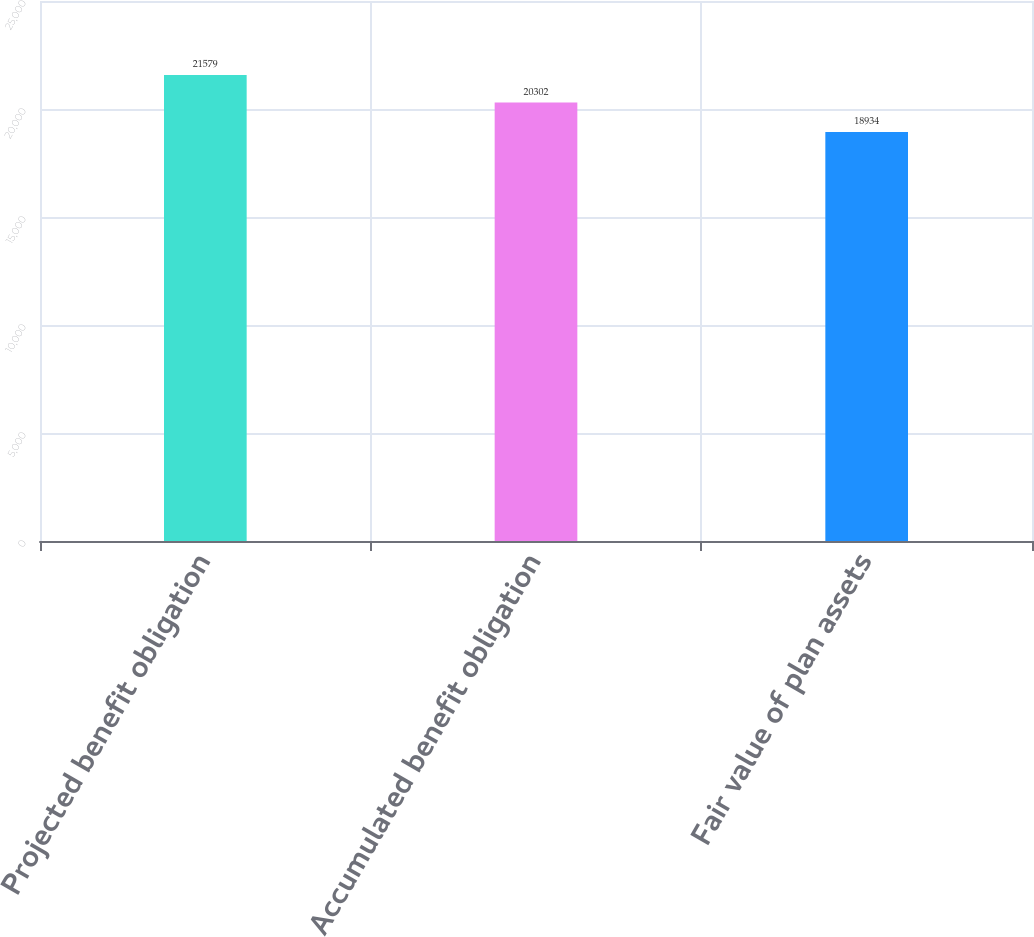<chart> <loc_0><loc_0><loc_500><loc_500><bar_chart><fcel>Projected benefit obligation<fcel>Accumulated benefit obligation<fcel>Fair value of plan assets<nl><fcel>21579<fcel>20302<fcel>18934<nl></chart> 